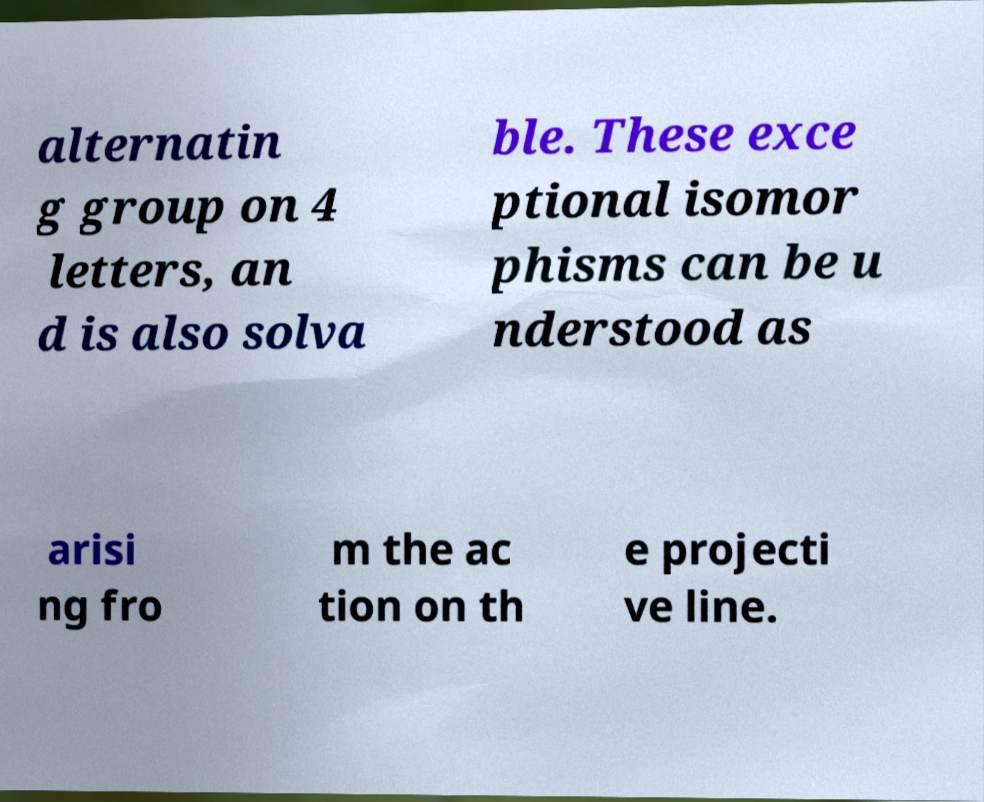Please read and relay the text visible in this image. What does it say? alternatin g group on 4 letters, an d is also solva ble. These exce ptional isomor phisms can be u nderstood as arisi ng fro m the ac tion on th e projecti ve line. 